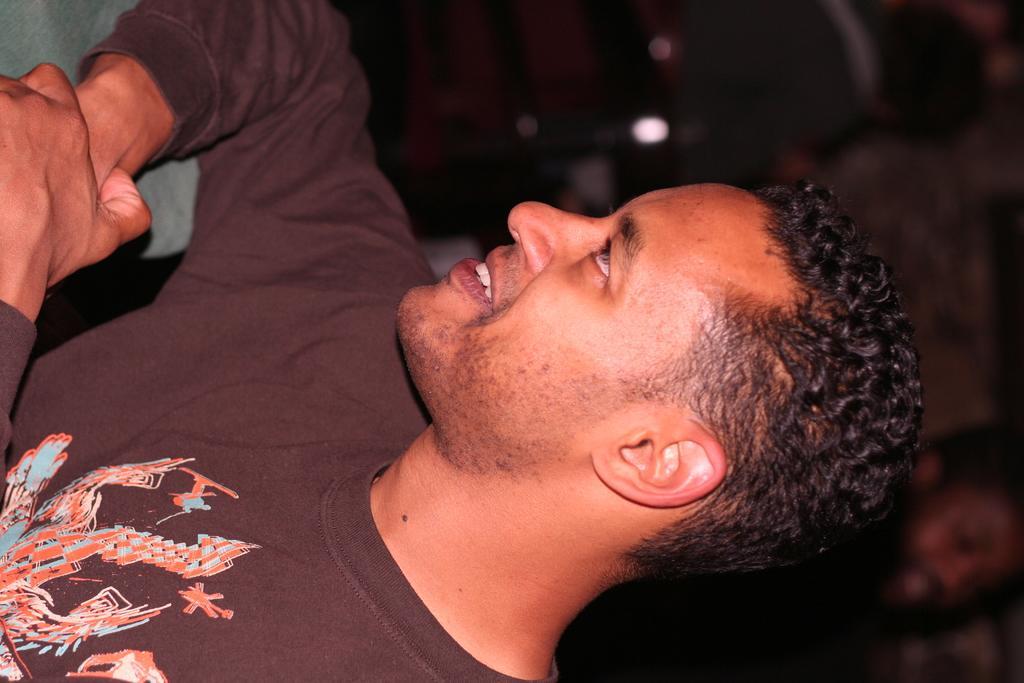Could you give a brief overview of what you see in this image? This image consists of a man wearing brown T-shirt. In the background, the image is blurred. 